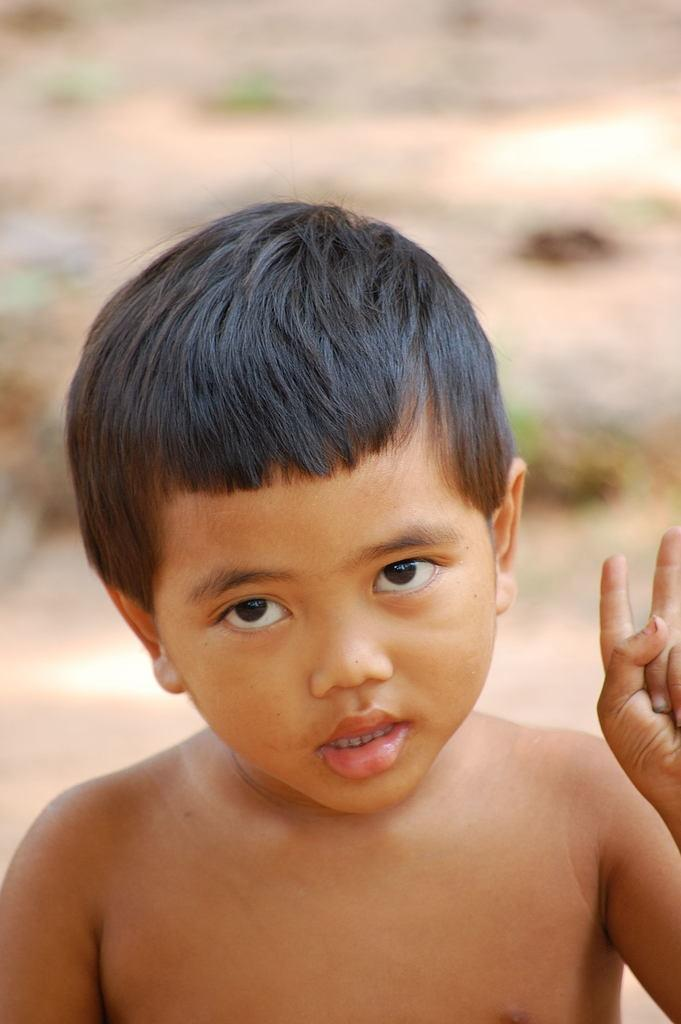What is the main subject of the picture? The main subject of the picture is a boy. What is the boy doing in the picture? The boy is showing two fingers in the picture. What direction is the sheep facing in the image? There is no sheep present in the image. How does the number of fingers the boy is showing increase in the image? The number of fingers the boy is showing does not increase in the image; he is only showing two fingers. 